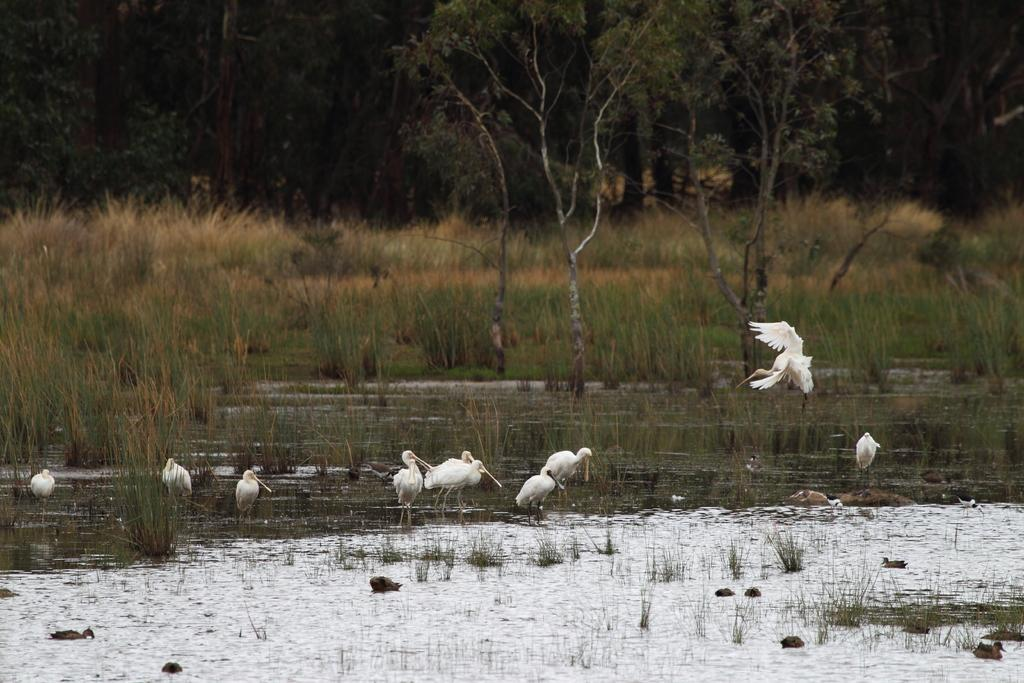What is located at the bottom of the picture? There is a crane at the bottom of the picture, along with water, ducks, and plants. What type of animals can be seen in the water? Ducks can be seen in the water. What is present in the center of the picture? There are trees and shrubs in the center of the picture. What can be seen in the background of the picture? There are trees in the background of the picture. How does the tent expand in the image? There is no tent present in the image. What sound does the bell make in the image? There is no bell present in the image. 